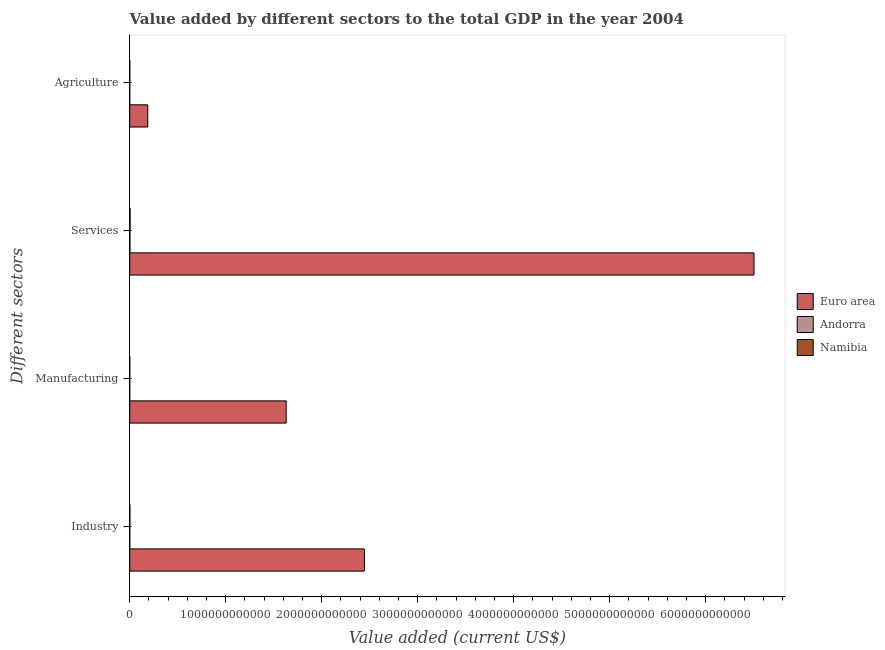Are the number of bars on each tick of the Y-axis equal?
Your answer should be compact. Yes. How many bars are there on the 3rd tick from the top?
Make the answer very short. 3. What is the label of the 3rd group of bars from the top?
Provide a short and direct response. Manufacturing. What is the value added by manufacturing sector in Euro area?
Give a very brief answer. 1.63e+12. Across all countries, what is the maximum value added by agricultural sector?
Your response must be concise. 1.88e+11. Across all countries, what is the minimum value added by manufacturing sector?
Offer a terse response. 1.04e+08. In which country was the value added by services sector minimum?
Your answer should be very brief. Andorra. What is the total value added by agricultural sector in the graph?
Keep it short and to the point. 1.89e+11. What is the difference between the value added by agricultural sector in Namibia and that in Andorra?
Make the answer very short. 5.78e+08. What is the difference between the value added by industrial sector in Andorra and the value added by agricultural sector in Euro area?
Provide a succinct answer. -1.87e+11. What is the average value added by industrial sector per country?
Provide a short and direct response. 8.16e+11. What is the difference between the value added by manufacturing sector and value added by industrial sector in Andorra?
Offer a very short reply. -3.58e+08. In how many countries, is the value added by industrial sector greater than 6600000000000 US$?
Give a very brief answer. 0. What is the ratio of the value added by agricultural sector in Euro area to that in Namibia?
Provide a short and direct response. 318.04. Is the value added by agricultural sector in Euro area less than that in Namibia?
Provide a short and direct response. No. Is the difference between the value added by manufacturing sector in Andorra and Namibia greater than the difference between the value added by agricultural sector in Andorra and Namibia?
Make the answer very short. No. What is the difference between the highest and the second highest value added by industrial sector?
Your response must be concise. 2.44e+12. What is the difference between the highest and the lowest value added by industrial sector?
Provide a short and direct response. 2.44e+12. Is it the case that in every country, the sum of the value added by industrial sector and value added by agricultural sector is greater than the sum of value added by services sector and value added by manufacturing sector?
Offer a terse response. No. What does the 1st bar from the top in Services represents?
Your answer should be compact. Namibia. What does the 3rd bar from the bottom in Manufacturing represents?
Give a very brief answer. Namibia. How many bars are there?
Keep it short and to the point. 12. How many countries are there in the graph?
Keep it short and to the point. 3. What is the difference between two consecutive major ticks on the X-axis?
Your response must be concise. 1.00e+12. Does the graph contain grids?
Keep it short and to the point. No. How many legend labels are there?
Give a very brief answer. 3. How are the legend labels stacked?
Provide a short and direct response. Vertical. What is the title of the graph?
Offer a terse response. Value added by different sectors to the total GDP in the year 2004. Does "Switzerland" appear as one of the legend labels in the graph?
Make the answer very short. No. What is the label or title of the X-axis?
Your response must be concise. Value added (current US$). What is the label or title of the Y-axis?
Offer a very short reply. Different sectors. What is the Value added (current US$) in Euro area in Industry?
Ensure brevity in your answer.  2.44e+12. What is the Value added (current US$) in Andorra in Industry?
Give a very brief answer. 4.62e+08. What is the Value added (current US$) in Namibia in Industry?
Your response must be concise. 1.78e+09. What is the Value added (current US$) in Euro area in Manufacturing?
Ensure brevity in your answer.  1.63e+12. What is the Value added (current US$) of Andorra in Manufacturing?
Your answer should be compact. 1.04e+08. What is the Value added (current US$) of Namibia in Manufacturing?
Provide a succinct answer. 8.26e+08. What is the Value added (current US$) of Euro area in Services?
Offer a terse response. 6.50e+12. What is the Value added (current US$) in Andorra in Services?
Keep it short and to the point. 2.19e+09. What is the Value added (current US$) of Namibia in Services?
Provide a short and direct response. 3.69e+09. What is the Value added (current US$) of Euro area in Agriculture?
Ensure brevity in your answer.  1.88e+11. What is the Value added (current US$) of Andorra in Agriculture?
Provide a succinct answer. 1.24e+07. What is the Value added (current US$) of Namibia in Agriculture?
Provide a short and direct response. 5.91e+08. Across all Different sectors, what is the maximum Value added (current US$) in Euro area?
Offer a terse response. 6.50e+12. Across all Different sectors, what is the maximum Value added (current US$) of Andorra?
Your answer should be very brief. 2.19e+09. Across all Different sectors, what is the maximum Value added (current US$) in Namibia?
Your response must be concise. 3.69e+09. Across all Different sectors, what is the minimum Value added (current US$) of Euro area?
Your answer should be very brief. 1.88e+11. Across all Different sectors, what is the minimum Value added (current US$) of Andorra?
Keep it short and to the point. 1.24e+07. Across all Different sectors, what is the minimum Value added (current US$) of Namibia?
Your response must be concise. 5.91e+08. What is the total Value added (current US$) of Euro area in the graph?
Ensure brevity in your answer.  1.08e+13. What is the total Value added (current US$) in Andorra in the graph?
Give a very brief answer. 2.77e+09. What is the total Value added (current US$) of Namibia in the graph?
Your answer should be very brief. 6.89e+09. What is the difference between the Value added (current US$) of Euro area in Industry and that in Manufacturing?
Your answer should be compact. 8.15e+11. What is the difference between the Value added (current US$) in Andorra in Industry and that in Manufacturing?
Your response must be concise. 3.58e+08. What is the difference between the Value added (current US$) in Namibia in Industry and that in Manufacturing?
Keep it short and to the point. 9.58e+08. What is the difference between the Value added (current US$) of Euro area in Industry and that in Services?
Ensure brevity in your answer.  -4.06e+12. What is the difference between the Value added (current US$) of Andorra in Industry and that in Services?
Ensure brevity in your answer.  -1.73e+09. What is the difference between the Value added (current US$) in Namibia in Industry and that in Services?
Provide a short and direct response. -1.91e+09. What is the difference between the Value added (current US$) in Euro area in Industry and that in Agriculture?
Make the answer very short. 2.26e+12. What is the difference between the Value added (current US$) of Andorra in Industry and that in Agriculture?
Give a very brief answer. 4.50e+08. What is the difference between the Value added (current US$) of Namibia in Industry and that in Agriculture?
Give a very brief answer. 1.19e+09. What is the difference between the Value added (current US$) in Euro area in Manufacturing and that in Services?
Offer a terse response. -4.87e+12. What is the difference between the Value added (current US$) of Andorra in Manufacturing and that in Services?
Your answer should be very brief. -2.09e+09. What is the difference between the Value added (current US$) in Namibia in Manufacturing and that in Services?
Give a very brief answer. -2.86e+09. What is the difference between the Value added (current US$) of Euro area in Manufacturing and that in Agriculture?
Give a very brief answer. 1.44e+12. What is the difference between the Value added (current US$) of Andorra in Manufacturing and that in Agriculture?
Keep it short and to the point. 9.20e+07. What is the difference between the Value added (current US$) in Namibia in Manufacturing and that in Agriculture?
Provide a short and direct response. 2.36e+08. What is the difference between the Value added (current US$) of Euro area in Services and that in Agriculture?
Your response must be concise. 6.31e+12. What is the difference between the Value added (current US$) in Andorra in Services and that in Agriculture?
Offer a very short reply. 2.18e+09. What is the difference between the Value added (current US$) of Namibia in Services and that in Agriculture?
Provide a succinct answer. 3.10e+09. What is the difference between the Value added (current US$) of Euro area in Industry and the Value added (current US$) of Andorra in Manufacturing?
Your response must be concise. 2.44e+12. What is the difference between the Value added (current US$) of Euro area in Industry and the Value added (current US$) of Namibia in Manufacturing?
Your response must be concise. 2.44e+12. What is the difference between the Value added (current US$) of Andorra in Industry and the Value added (current US$) of Namibia in Manufacturing?
Provide a succinct answer. -3.64e+08. What is the difference between the Value added (current US$) in Euro area in Industry and the Value added (current US$) in Andorra in Services?
Your answer should be very brief. 2.44e+12. What is the difference between the Value added (current US$) in Euro area in Industry and the Value added (current US$) in Namibia in Services?
Your answer should be very brief. 2.44e+12. What is the difference between the Value added (current US$) in Andorra in Industry and the Value added (current US$) in Namibia in Services?
Provide a succinct answer. -3.23e+09. What is the difference between the Value added (current US$) of Euro area in Industry and the Value added (current US$) of Andorra in Agriculture?
Your answer should be very brief. 2.44e+12. What is the difference between the Value added (current US$) in Euro area in Industry and the Value added (current US$) in Namibia in Agriculture?
Provide a succinct answer. 2.44e+12. What is the difference between the Value added (current US$) of Andorra in Industry and the Value added (current US$) of Namibia in Agriculture?
Offer a terse response. -1.29e+08. What is the difference between the Value added (current US$) in Euro area in Manufacturing and the Value added (current US$) in Andorra in Services?
Your answer should be compact. 1.63e+12. What is the difference between the Value added (current US$) in Euro area in Manufacturing and the Value added (current US$) in Namibia in Services?
Offer a terse response. 1.63e+12. What is the difference between the Value added (current US$) in Andorra in Manufacturing and the Value added (current US$) in Namibia in Services?
Your answer should be very brief. -3.59e+09. What is the difference between the Value added (current US$) of Euro area in Manufacturing and the Value added (current US$) of Andorra in Agriculture?
Your answer should be compact. 1.63e+12. What is the difference between the Value added (current US$) of Euro area in Manufacturing and the Value added (current US$) of Namibia in Agriculture?
Make the answer very short. 1.63e+12. What is the difference between the Value added (current US$) of Andorra in Manufacturing and the Value added (current US$) of Namibia in Agriculture?
Your answer should be compact. -4.87e+08. What is the difference between the Value added (current US$) of Euro area in Services and the Value added (current US$) of Andorra in Agriculture?
Provide a short and direct response. 6.50e+12. What is the difference between the Value added (current US$) of Euro area in Services and the Value added (current US$) of Namibia in Agriculture?
Offer a terse response. 6.50e+12. What is the difference between the Value added (current US$) in Andorra in Services and the Value added (current US$) in Namibia in Agriculture?
Make the answer very short. 1.60e+09. What is the average Value added (current US$) in Euro area per Different sectors?
Offer a terse response. 2.69e+12. What is the average Value added (current US$) of Andorra per Different sectors?
Your answer should be compact. 6.93e+08. What is the average Value added (current US$) in Namibia per Different sectors?
Your response must be concise. 1.72e+09. What is the difference between the Value added (current US$) in Euro area and Value added (current US$) in Andorra in Industry?
Keep it short and to the point. 2.44e+12. What is the difference between the Value added (current US$) of Euro area and Value added (current US$) of Namibia in Industry?
Your answer should be very brief. 2.44e+12. What is the difference between the Value added (current US$) in Andorra and Value added (current US$) in Namibia in Industry?
Provide a succinct answer. -1.32e+09. What is the difference between the Value added (current US$) of Euro area and Value added (current US$) of Andorra in Manufacturing?
Offer a very short reply. 1.63e+12. What is the difference between the Value added (current US$) in Euro area and Value added (current US$) in Namibia in Manufacturing?
Your answer should be compact. 1.63e+12. What is the difference between the Value added (current US$) of Andorra and Value added (current US$) of Namibia in Manufacturing?
Ensure brevity in your answer.  -7.22e+08. What is the difference between the Value added (current US$) of Euro area and Value added (current US$) of Andorra in Services?
Give a very brief answer. 6.50e+12. What is the difference between the Value added (current US$) in Euro area and Value added (current US$) in Namibia in Services?
Ensure brevity in your answer.  6.50e+12. What is the difference between the Value added (current US$) in Andorra and Value added (current US$) in Namibia in Services?
Make the answer very short. -1.50e+09. What is the difference between the Value added (current US$) in Euro area and Value added (current US$) in Andorra in Agriculture?
Ensure brevity in your answer.  1.88e+11. What is the difference between the Value added (current US$) of Euro area and Value added (current US$) of Namibia in Agriculture?
Your answer should be compact. 1.87e+11. What is the difference between the Value added (current US$) of Andorra and Value added (current US$) of Namibia in Agriculture?
Provide a short and direct response. -5.78e+08. What is the ratio of the Value added (current US$) of Euro area in Industry to that in Manufacturing?
Offer a terse response. 1.5. What is the ratio of the Value added (current US$) of Andorra in Industry to that in Manufacturing?
Your response must be concise. 4.43. What is the ratio of the Value added (current US$) in Namibia in Industry to that in Manufacturing?
Make the answer very short. 2.16. What is the ratio of the Value added (current US$) in Euro area in Industry to that in Services?
Your answer should be compact. 0.38. What is the ratio of the Value added (current US$) of Andorra in Industry to that in Services?
Keep it short and to the point. 0.21. What is the ratio of the Value added (current US$) of Namibia in Industry to that in Services?
Your answer should be compact. 0.48. What is the ratio of the Value added (current US$) of Euro area in Industry to that in Agriculture?
Provide a succinct answer. 13.01. What is the ratio of the Value added (current US$) of Andorra in Industry to that in Agriculture?
Ensure brevity in your answer.  37.41. What is the ratio of the Value added (current US$) in Namibia in Industry to that in Agriculture?
Offer a very short reply. 3.02. What is the ratio of the Value added (current US$) of Euro area in Manufacturing to that in Services?
Make the answer very short. 0.25. What is the ratio of the Value added (current US$) of Andorra in Manufacturing to that in Services?
Give a very brief answer. 0.05. What is the ratio of the Value added (current US$) in Namibia in Manufacturing to that in Services?
Provide a short and direct response. 0.22. What is the ratio of the Value added (current US$) in Euro area in Manufacturing to that in Agriculture?
Your answer should be very brief. 8.67. What is the ratio of the Value added (current US$) in Andorra in Manufacturing to that in Agriculture?
Your answer should be compact. 8.44. What is the ratio of the Value added (current US$) of Namibia in Manufacturing to that in Agriculture?
Provide a short and direct response. 1.4. What is the ratio of the Value added (current US$) of Euro area in Services to that in Agriculture?
Make the answer very short. 34.6. What is the ratio of the Value added (current US$) of Andorra in Services to that in Agriculture?
Ensure brevity in your answer.  177.62. What is the ratio of the Value added (current US$) in Namibia in Services to that in Agriculture?
Provide a succinct answer. 6.24. What is the difference between the highest and the second highest Value added (current US$) in Euro area?
Make the answer very short. 4.06e+12. What is the difference between the highest and the second highest Value added (current US$) of Andorra?
Your response must be concise. 1.73e+09. What is the difference between the highest and the second highest Value added (current US$) of Namibia?
Give a very brief answer. 1.91e+09. What is the difference between the highest and the lowest Value added (current US$) in Euro area?
Provide a succinct answer. 6.31e+12. What is the difference between the highest and the lowest Value added (current US$) in Andorra?
Provide a short and direct response. 2.18e+09. What is the difference between the highest and the lowest Value added (current US$) of Namibia?
Offer a terse response. 3.10e+09. 